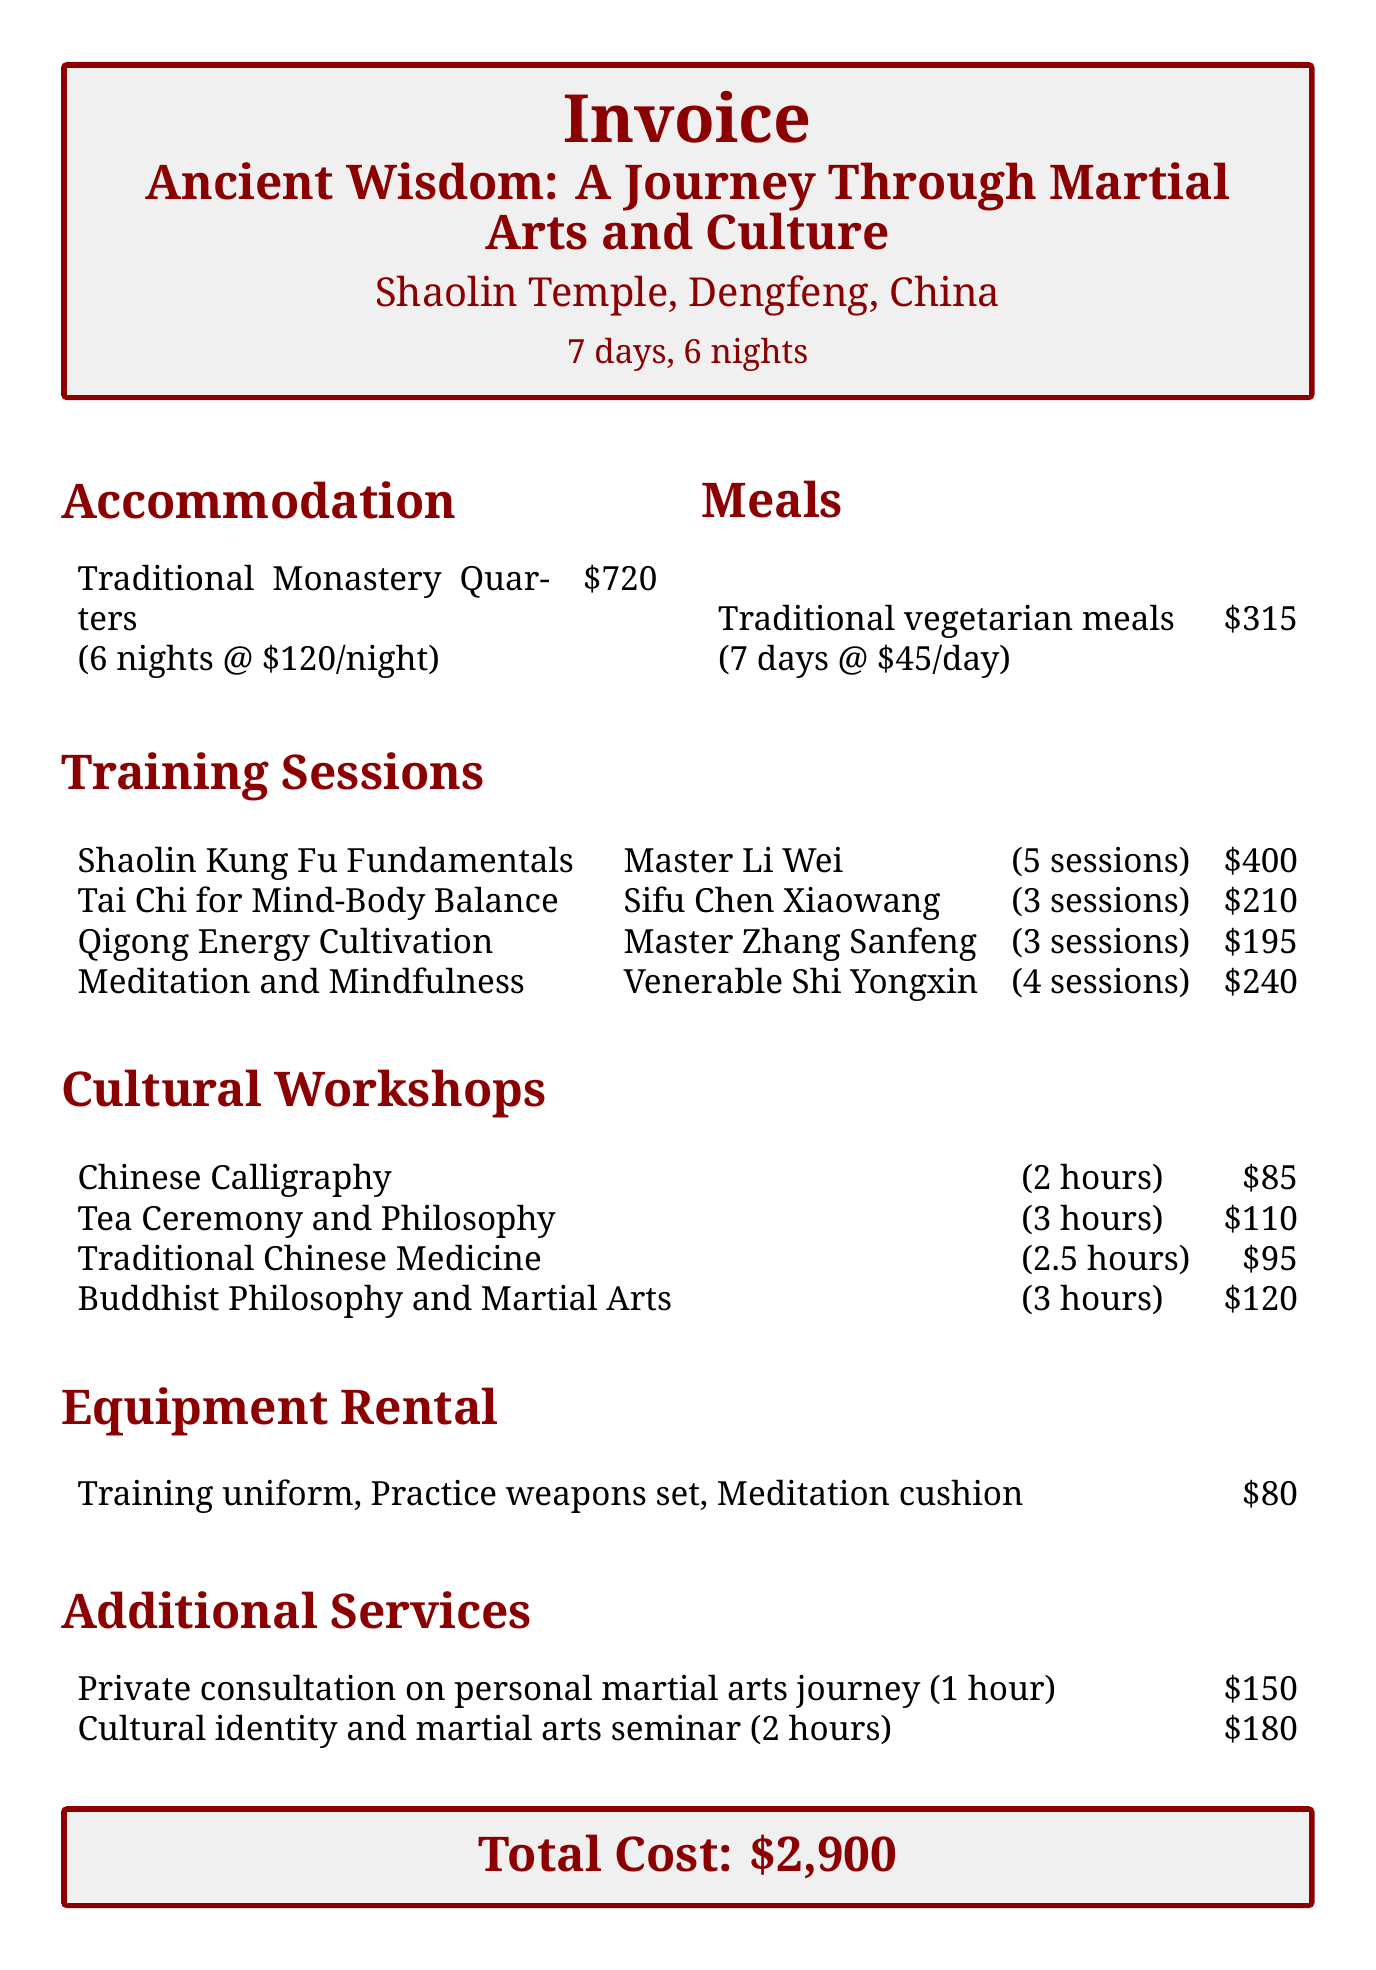What is the name of the retreat? The name of the retreat is specified at the top of the document under the title.
Answer: Ancient Wisdom: A Journey Through Martial Arts and Culture How many nights of accommodation are included? The document lists the nights of accommodation under the accommodation section.
Answer: 6 nights Who is the instructor for the Tai Chi training session? The instructor's name is provided in the training sessions section for each session.
Answer: Sifu Chen Xiaowang What is the cost of the private consultation service? The cost is listed alongside the description of the service in the additional services section.
Answer: 150 What is the total cost of the retreat? The total cost is clearly summarized at the end of the document.
Answer: 2900 How many training sessions are offered for Qigong Energy Cultivation? The number of sessions is stated in the training sessions table.
Answer: 3 sessions What type of accommodation is provided? The accommodation type is mentioned in the accommodation section of the document.
Answer: Traditional Monastery Quarters How many cultural workshops are listed? The total number of cultural workshops can be counted from the corresponding section.
Answer: 4 workshops What is the cost per day for meals? The cost per day for meals is specified in the meals section of the document.
Answer: 45 